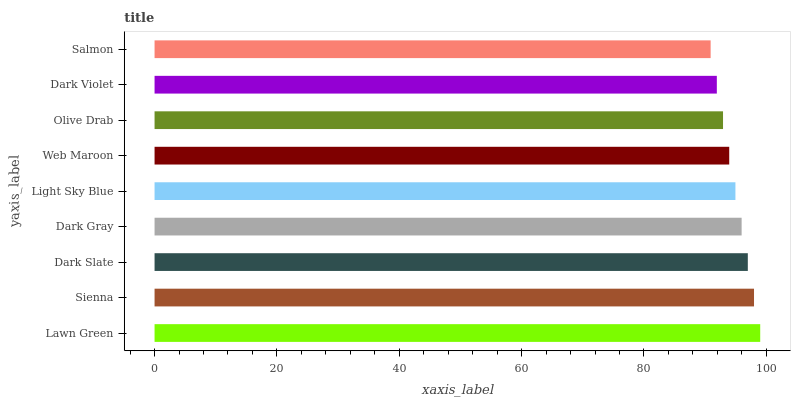Is Salmon the minimum?
Answer yes or no. Yes. Is Lawn Green the maximum?
Answer yes or no. Yes. Is Sienna the minimum?
Answer yes or no. No. Is Sienna the maximum?
Answer yes or no. No. Is Lawn Green greater than Sienna?
Answer yes or no. Yes. Is Sienna less than Lawn Green?
Answer yes or no. Yes. Is Sienna greater than Lawn Green?
Answer yes or no. No. Is Lawn Green less than Sienna?
Answer yes or no. No. Is Light Sky Blue the high median?
Answer yes or no. Yes. Is Light Sky Blue the low median?
Answer yes or no. Yes. Is Dark Gray the high median?
Answer yes or no. No. Is Dark Slate the low median?
Answer yes or no. No. 